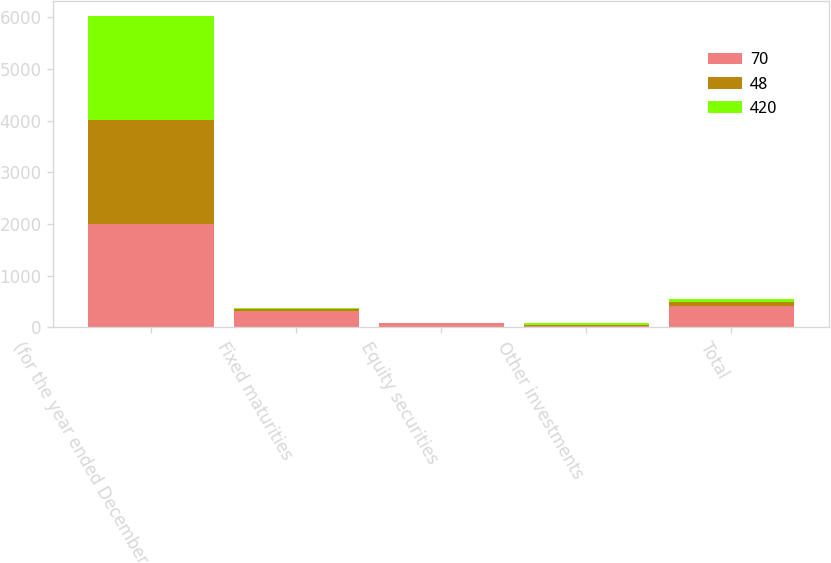Convert chart to OTSL. <chart><loc_0><loc_0><loc_500><loc_500><stacked_bar_chart><ecel><fcel>(for the year ended December<fcel>Fixed maturities<fcel>Equity securities<fcel>Other investments<fcel>Total<nl><fcel>70<fcel>2008<fcel>324<fcel>74<fcel>22<fcel>420<nl><fcel>48<fcel>2007<fcel>37<fcel>7<fcel>26<fcel>70<nl><fcel>420<fcel>2006<fcel>7<fcel>4<fcel>37<fcel>48<nl></chart> 